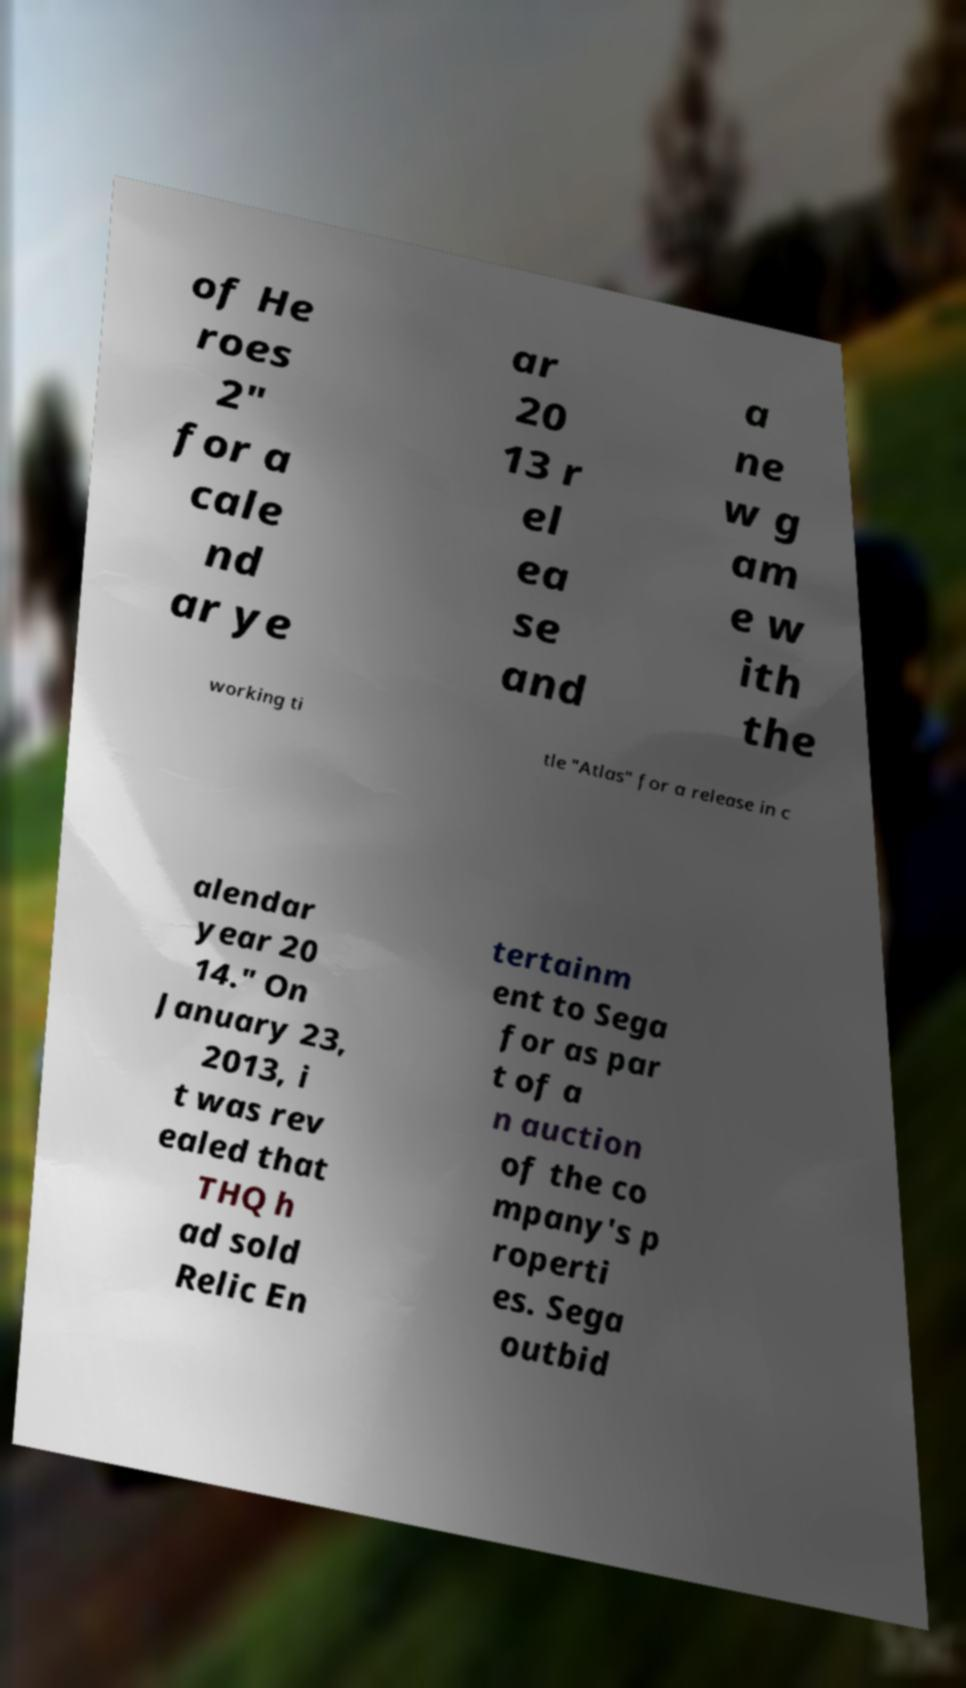I need the written content from this picture converted into text. Can you do that? of He roes 2" for a cale nd ar ye ar 20 13 r el ea se and a ne w g am e w ith the working ti tle "Atlas" for a release in c alendar year 20 14." On January 23, 2013, i t was rev ealed that THQ h ad sold Relic En tertainm ent to Sega for as par t of a n auction of the co mpany's p roperti es. Sega outbid 